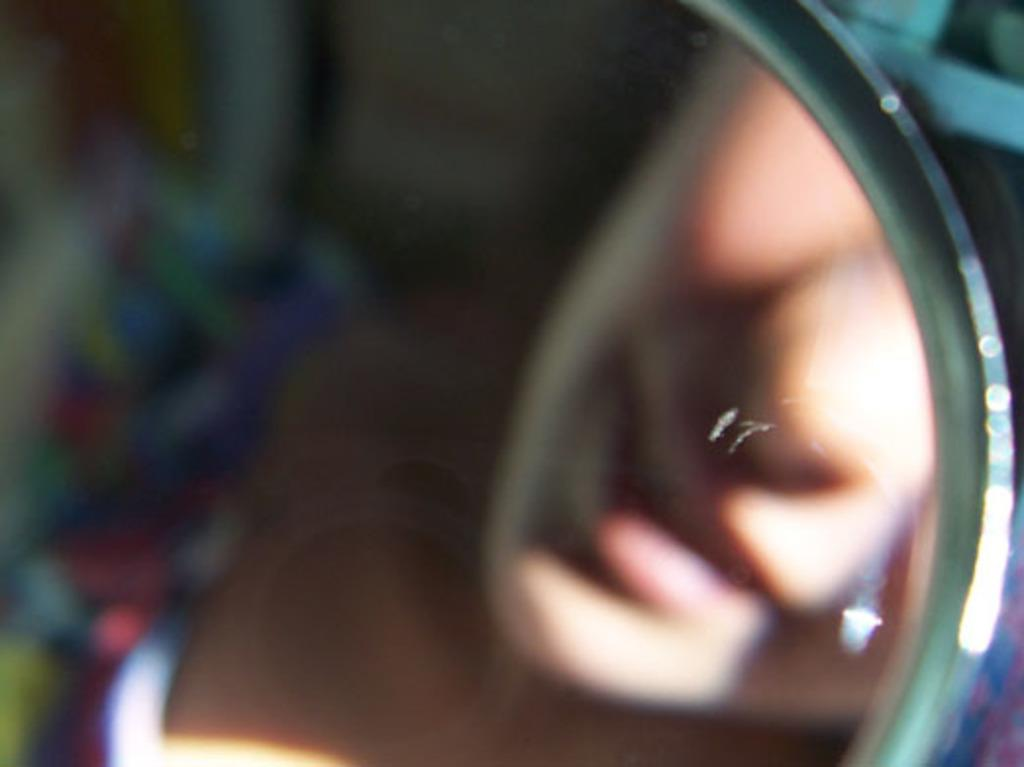What is the main subject of the image? The main subject of the image is a person's face. Where is the person's face located in the image? The person's face is visible in a mirror. How clear is the image of the person's face? The image of the person's face is blurry. Can you tell me how many streams are visible in the image? There are no streams visible in the image; it features a person's face in a mirror. What type of road is shown in the image? There is no road present in the image; it features a person's face in a mirror. 